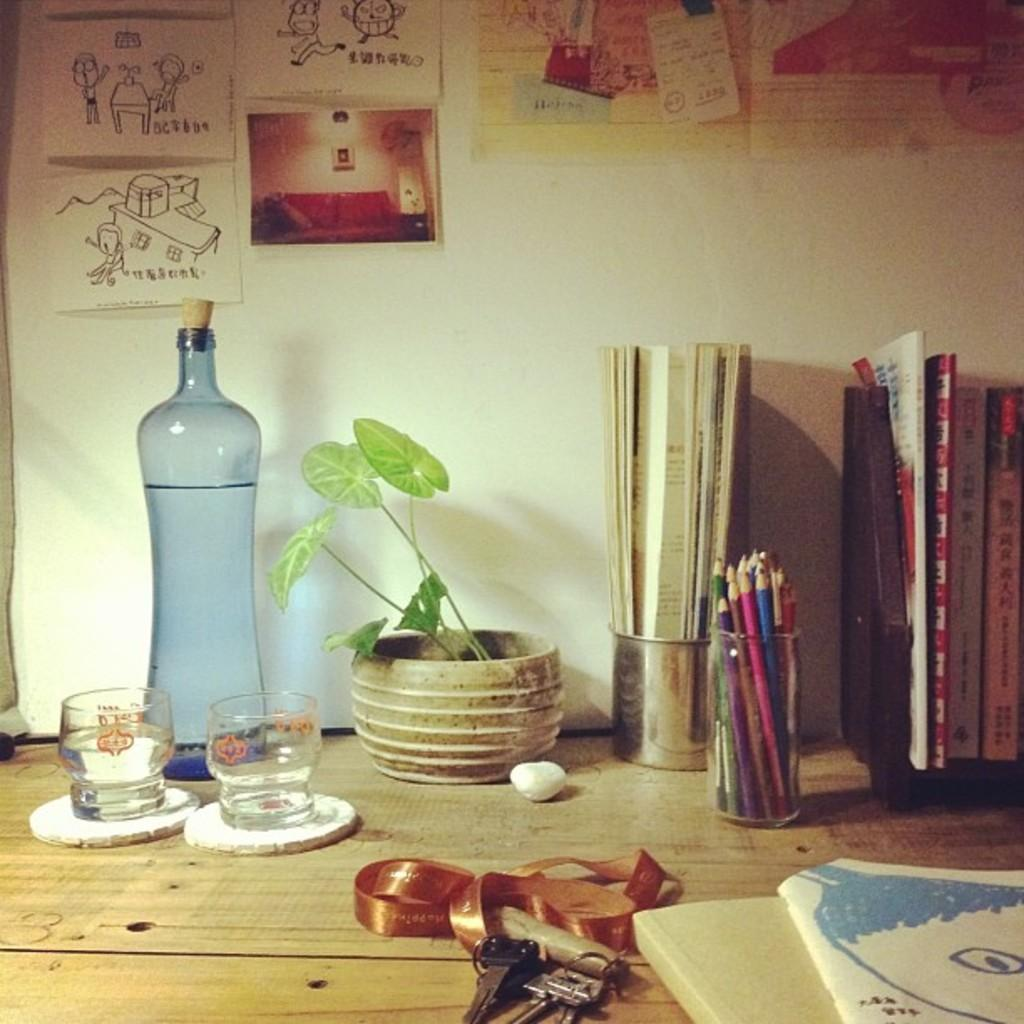What object can be seen in the image that is typically used for holding liquids? There is a bottle in the image. What living organism is present in the image? There is a plant in the image. What object can be seen in the image that is typically used for drinking? There is a glass in the image. What objects can be seen in the image that are typically used for unlocking doors? There are keys in the image. What objects can be seen in the image that are typically used for reading? There are books in the image. What objects can be seen in the image that are typically used for writing? There are pencils in the image. What can be seen in the background of the image that is on a vertical surface? There are posters on the wall in the background. What is visible in the background of the image that separates the space? There is a wall visible in the background. What type of car is parked in front of the wall in the image? There is no car present in the image. How many firemen can be seen in the image? There are no firemen present in the image. 